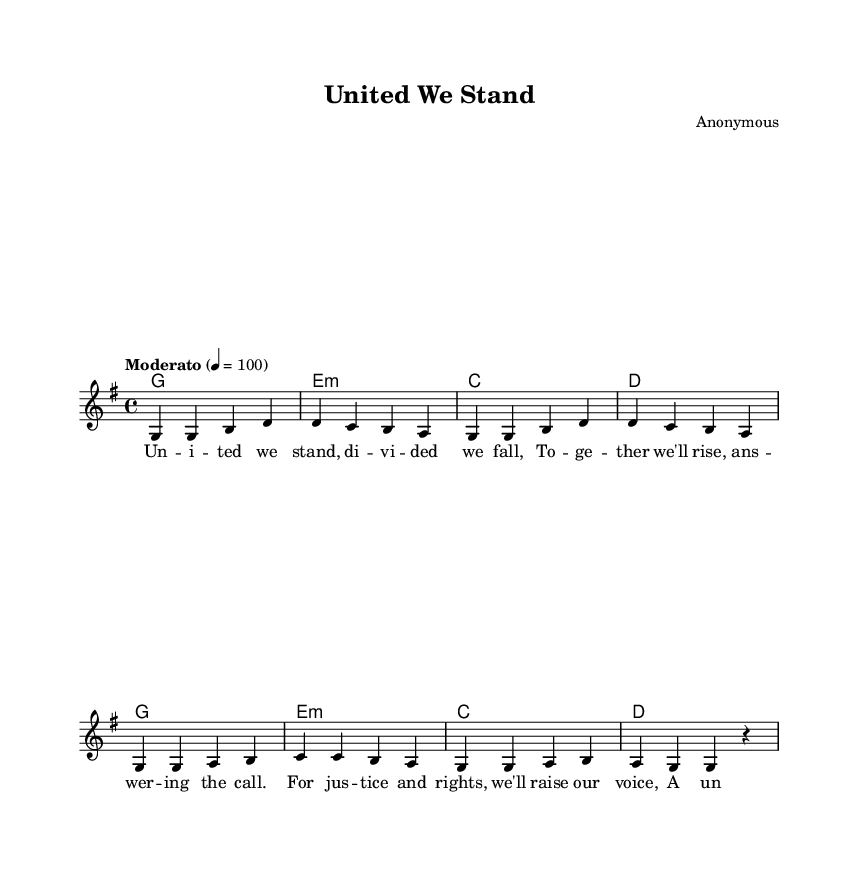What is the key signature of this music? The key signature has one sharp, indicating that it is in G major. The presence of a F# in the scale confirms this key.
Answer: G major What is the time signature of this music? The time signature is indicated at the beginning of the sheet music, which shows it as 4/4, meaning each measure has four beats and a quarter note receives one beat.
Answer: 4/4 What is the tempo marking for this piece? The tempo marking appears at the beginning and specifies "Moderato," which indicates a moderate tempo. A metronome marking of 100 beats per minute is also provided alongside this marking.
Answer: Moderato How many measures are in the melody? By counting the distinct groups of notes separated by bars in the sheet music, there are a total of eight measures for the melody, evidenced by the repetitive four-bar structure complemented by a repeated four-bar phrase.
Answer: Eight What is the chord progression for the first line of the lyrics? The chord progression can be determined by observing the chord symbols above the staff. For the first line of lyrics, the chord progression is G - E minor - C - D.
Answer: G, E minor, C, D What is the pattern of the lyrics in relation to the melody? By analyzing the lyrics, we can see that they follow a structured approach with each syllable of the lyrics generally aligning with a note in the melody, ensuring that the message is clear and rhythmic. This repetitive pattern enhances the overall flow of the song.
Answer: Syllabic alignment What type of song is "United We Stand"? The song falls under the category of folk protest songs, which are known for addressing social issues and labor rights, reflective of the 1960s movement. This categorization is derived from both its content and historical context.
Answer: Folk protest song 